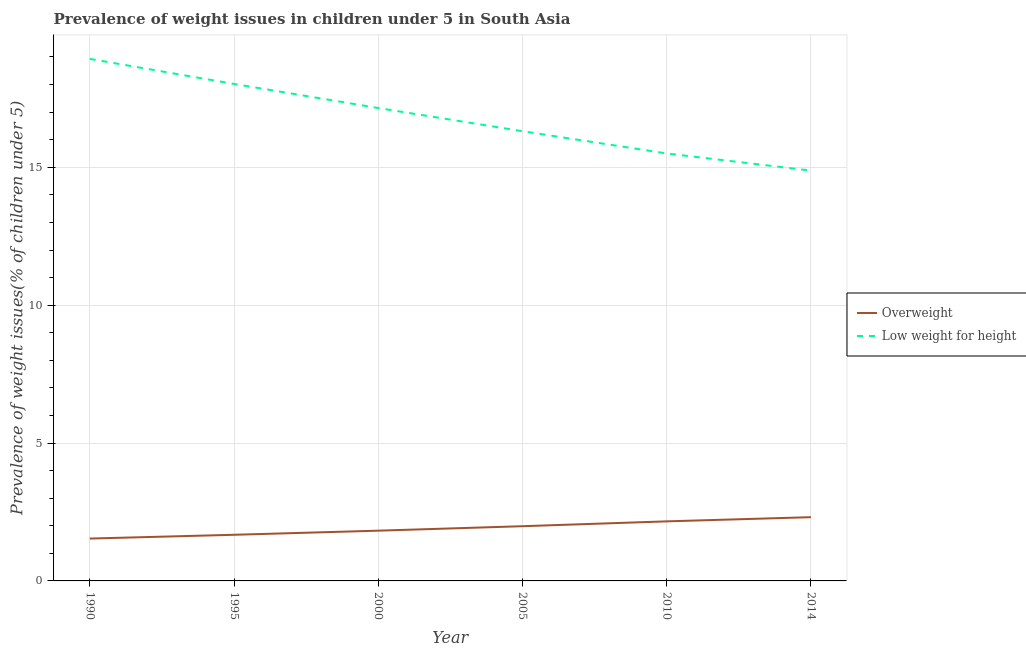How many different coloured lines are there?
Provide a short and direct response. 2. What is the percentage of underweight children in 1990?
Your answer should be compact. 18.93. Across all years, what is the maximum percentage of underweight children?
Make the answer very short. 18.93. Across all years, what is the minimum percentage of overweight children?
Offer a terse response. 1.54. What is the total percentage of underweight children in the graph?
Provide a short and direct response. 100.79. What is the difference between the percentage of underweight children in 2000 and that in 2010?
Your answer should be compact. 1.65. What is the difference between the percentage of overweight children in 2005 and the percentage of underweight children in 2014?
Make the answer very short. -12.9. What is the average percentage of underweight children per year?
Keep it short and to the point. 16.8. In the year 2000, what is the difference between the percentage of underweight children and percentage of overweight children?
Provide a short and direct response. 15.33. What is the ratio of the percentage of underweight children in 1990 to that in 2005?
Your response must be concise. 1.16. What is the difference between the highest and the second highest percentage of overweight children?
Make the answer very short. 0.15. What is the difference between the highest and the lowest percentage of underweight children?
Ensure brevity in your answer.  4.05. Does the percentage of overweight children monotonically increase over the years?
Make the answer very short. Yes. Is the percentage of overweight children strictly greater than the percentage of underweight children over the years?
Offer a terse response. No. Is the percentage of overweight children strictly less than the percentage of underweight children over the years?
Your answer should be very brief. Yes. How many years are there in the graph?
Offer a terse response. 6. Does the graph contain grids?
Your answer should be compact. Yes. Where does the legend appear in the graph?
Provide a succinct answer. Center right. How many legend labels are there?
Your answer should be compact. 2. How are the legend labels stacked?
Provide a short and direct response. Vertical. What is the title of the graph?
Provide a succinct answer. Prevalence of weight issues in children under 5 in South Asia. What is the label or title of the X-axis?
Your answer should be very brief. Year. What is the label or title of the Y-axis?
Offer a terse response. Prevalence of weight issues(% of children under 5). What is the Prevalence of weight issues(% of children under 5) of Overweight in 1990?
Provide a short and direct response. 1.54. What is the Prevalence of weight issues(% of children under 5) of Low weight for height in 1990?
Your response must be concise. 18.93. What is the Prevalence of weight issues(% of children under 5) of Overweight in 1995?
Keep it short and to the point. 1.67. What is the Prevalence of weight issues(% of children under 5) in Low weight for height in 1995?
Keep it short and to the point. 18.02. What is the Prevalence of weight issues(% of children under 5) in Overweight in 2000?
Provide a short and direct response. 1.82. What is the Prevalence of weight issues(% of children under 5) of Low weight for height in 2000?
Make the answer very short. 17.15. What is the Prevalence of weight issues(% of children under 5) in Overweight in 2005?
Make the answer very short. 1.98. What is the Prevalence of weight issues(% of children under 5) of Low weight for height in 2005?
Keep it short and to the point. 16.31. What is the Prevalence of weight issues(% of children under 5) in Overweight in 2010?
Make the answer very short. 2.16. What is the Prevalence of weight issues(% of children under 5) in Low weight for height in 2010?
Your answer should be compact. 15.5. What is the Prevalence of weight issues(% of children under 5) in Overweight in 2014?
Give a very brief answer. 2.31. What is the Prevalence of weight issues(% of children under 5) of Low weight for height in 2014?
Provide a succinct answer. 14.88. Across all years, what is the maximum Prevalence of weight issues(% of children under 5) of Overweight?
Your response must be concise. 2.31. Across all years, what is the maximum Prevalence of weight issues(% of children under 5) of Low weight for height?
Offer a terse response. 18.93. Across all years, what is the minimum Prevalence of weight issues(% of children under 5) of Overweight?
Offer a terse response. 1.54. Across all years, what is the minimum Prevalence of weight issues(% of children under 5) in Low weight for height?
Keep it short and to the point. 14.88. What is the total Prevalence of weight issues(% of children under 5) of Overweight in the graph?
Provide a short and direct response. 11.49. What is the total Prevalence of weight issues(% of children under 5) in Low weight for height in the graph?
Make the answer very short. 100.79. What is the difference between the Prevalence of weight issues(% of children under 5) in Overweight in 1990 and that in 1995?
Your answer should be compact. -0.14. What is the difference between the Prevalence of weight issues(% of children under 5) in Low weight for height in 1990 and that in 1995?
Offer a very short reply. 0.91. What is the difference between the Prevalence of weight issues(% of children under 5) of Overweight in 1990 and that in 2000?
Offer a very short reply. -0.29. What is the difference between the Prevalence of weight issues(% of children under 5) in Low weight for height in 1990 and that in 2000?
Offer a very short reply. 1.78. What is the difference between the Prevalence of weight issues(% of children under 5) in Overweight in 1990 and that in 2005?
Keep it short and to the point. -0.45. What is the difference between the Prevalence of weight issues(% of children under 5) in Low weight for height in 1990 and that in 2005?
Provide a succinct answer. 2.62. What is the difference between the Prevalence of weight issues(% of children under 5) in Overweight in 1990 and that in 2010?
Your answer should be compact. -0.62. What is the difference between the Prevalence of weight issues(% of children under 5) of Low weight for height in 1990 and that in 2010?
Ensure brevity in your answer.  3.43. What is the difference between the Prevalence of weight issues(% of children under 5) of Overweight in 1990 and that in 2014?
Ensure brevity in your answer.  -0.78. What is the difference between the Prevalence of weight issues(% of children under 5) of Low weight for height in 1990 and that in 2014?
Provide a succinct answer. 4.05. What is the difference between the Prevalence of weight issues(% of children under 5) in Overweight in 1995 and that in 2000?
Provide a short and direct response. -0.15. What is the difference between the Prevalence of weight issues(% of children under 5) in Low weight for height in 1995 and that in 2000?
Your response must be concise. 0.87. What is the difference between the Prevalence of weight issues(% of children under 5) in Overweight in 1995 and that in 2005?
Your answer should be very brief. -0.31. What is the difference between the Prevalence of weight issues(% of children under 5) in Low weight for height in 1995 and that in 2005?
Provide a succinct answer. 1.71. What is the difference between the Prevalence of weight issues(% of children under 5) in Overweight in 1995 and that in 2010?
Offer a terse response. -0.49. What is the difference between the Prevalence of weight issues(% of children under 5) of Low weight for height in 1995 and that in 2010?
Give a very brief answer. 2.52. What is the difference between the Prevalence of weight issues(% of children under 5) in Overweight in 1995 and that in 2014?
Give a very brief answer. -0.64. What is the difference between the Prevalence of weight issues(% of children under 5) in Low weight for height in 1995 and that in 2014?
Ensure brevity in your answer.  3.14. What is the difference between the Prevalence of weight issues(% of children under 5) of Overweight in 2000 and that in 2005?
Your response must be concise. -0.16. What is the difference between the Prevalence of weight issues(% of children under 5) in Low weight for height in 2000 and that in 2005?
Your answer should be very brief. 0.84. What is the difference between the Prevalence of weight issues(% of children under 5) in Overweight in 2000 and that in 2010?
Your answer should be very brief. -0.34. What is the difference between the Prevalence of weight issues(% of children under 5) in Low weight for height in 2000 and that in 2010?
Keep it short and to the point. 1.65. What is the difference between the Prevalence of weight issues(% of children under 5) in Overweight in 2000 and that in 2014?
Provide a succinct answer. -0.49. What is the difference between the Prevalence of weight issues(% of children under 5) of Low weight for height in 2000 and that in 2014?
Ensure brevity in your answer.  2.27. What is the difference between the Prevalence of weight issues(% of children under 5) in Overweight in 2005 and that in 2010?
Your response must be concise. -0.18. What is the difference between the Prevalence of weight issues(% of children under 5) in Low weight for height in 2005 and that in 2010?
Keep it short and to the point. 0.81. What is the difference between the Prevalence of weight issues(% of children under 5) in Overweight in 2005 and that in 2014?
Your answer should be very brief. -0.33. What is the difference between the Prevalence of weight issues(% of children under 5) in Low weight for height in 2005 and that in 2014?
Ensure brevity in your answer.  1.43. What is the difference between the Prevalence of weight issues(% of children under 5) of Overweight in 2010 and that in 2014?
Offer a very short reply. -0.15. What is the difference between the Prevalence of weight issues(% of children under 5) in Low weight for height in 2010 and that in 2014?
Make the answer very short. 0.62. What is the difference between the Prevalence of weight issues(% of children under 5) of Overweight in 1990 and the Prevalence of weight issues(% of children under 5) of Low weight for height in 1995?
Give a very brief answer. -16.49. What is the difference between the Prevalence of weight issues(% of children under 5) of Overweight in 1990 and the Prevalence of weight issues(% of children under 5) of Low weight for height in 2000?
Offer a very short reply. -15.61. What is the difference between the Prevalence of weight issues(% of children under 5) in Overweight in 1990 and the Prevalence of weight issues(% of children under 5) in Low weight for height in 2005?
Your response must be concise. -14.77. What is the difference between the Prevalence of weight issues(% of children under 5) of Overweight in 1990 and the Prevalence of weight issues(% of children under 5) of Low weight for height in 2010?
Your answer should be compact. -13.97. What is the difference between the Prevalence of weight issues(% of children under 5) of Overweight in 1990 and the Prevalence of weight issues(% of children under 5) of Low weight for height in 2014?
Your response must be concise. -13.34. What is the difference between the Prevalence of weight issues(% of children under 5) of Overweight in 1995 and the Prevalence of weight issues(% of children under 5) of Low weight for height in 2000?
Offer a terse response. -15.48. What is the difference between the Prevalence of weight issues(% of children under 5) of Overweight in 1995 and the Prevalence of weight issues(% of children under 5) of Low weight for height in 2005?
Keep it short and to the point. -14.63. What is the difference between the Prevalence of weight issues(% of children under 5) of Overweight in 1995 and the Prevalence of weight issues(% of children under 5) of Low weight for height in 2010?
Keep it short and to the point. -13.83. What is the difference between the Prevalence of weight issues(% of children under 5) in Overweight in 1995 and the Prevalence of weight issues(% of children under 5) in Low weight for height in 2014?
Your answer should be very brief. -13.21. What is the difference between the Prevalence of weight issues(% of children under 5) of Overweight in 2000 and the Prevalence of weight issues(% of children under 5) of Low weight for height in 2005?
Offer a very short reply. -14.49. What is the difference between the Prevalence of weight issues(% of children under 5) in Overweight in 2000 and the Prevalence of weight issues(% of children under 5) in Low weight for height in 2010?
Your answer should be very brief. -13.68. What is the difference between the Prevalence of weight issues(% of children under 5) in Overweight in 2000 and the Prevalence of weight issues(% of children under 5) in Low weight for height in 2014?
Your answer should be compact. -13.06. What is the difference between the Prevalence of weight issues(% of children under 5) of Overweight in 2005 and the Prevalence of weight issues(% of children under 5) of Low weight for height in 2010?
Offer a terse response. -13.52. What is the difference between the Prevalence of weight issues(% of children under 5) of Overweight in 2005 and the Prevalence of weight issues(% of children under 5) of Low weight for height in 2014?
Ensure brevity in your answer.  -12.9. What is the difference between the Prevalence of weight issues(% of children under 5) in Overweight in 2010 and the Prevalence of weight issues(% of children under 5) in Low weight for height in 2014?
Your answer should be very brief. -12.72. What is the average Prevalence of weight issues(% of children under 5) of Overweight per year?
Provide a short and direct response. 1.91. What is the average Prevalence of weight issues(% of children under 5) in Low weight for height per year?
Give a very brief answer. 16.8. In the year 1990, what is the difference between the Prevalence of weight issues(% of children under 5) of Overweight and Prevalence of weight issues(% of children under 5) of Low weight for height?
Keep it short and to the point. -17.4. In the year 1995, what is the difference between the Prevalence of weight issues(% of children under 5) of Overweight and Prevalence of weight issues(% of children under 5) of Low weight for height?
Provide a short and direct response. -16.35. In the year 2000, what is the difference between the Prevalence of weight issues(% of children under 5) of Overweight and Prevalence of weight issues(% of children under 5) of Low weight for height?
Your response must be concise. -15.33. In the year 2005, what is the difference between the Prevalence of weight issues(% of children under 5) of Overweight and Prevalence of weight issues(% of children under 5) of Low weight for height?
Ensure brevity in your answer.  -14.32. In the year 2010, what is the difference between the Prevalence of weight issues(% of children under 5) in Overweight and Prevalence of weight issues(% of children under 5) in Low weight for height?
Offer a terse response. -13.34. In the year 2014, what is the difference between the Prevalence of weight issues(% of children under 5) of Overweight and Prevalence of weight issues(% of children under 5) of Low weight for height?
Your answer should be compact. -12.57. What is the ratio of the Prevalence of weight issues(% of children under 5) in Overweight in 1990 to that in 1995?
Offer a very short reply. 0.92. What is the ratio of the Prevalence of weight issues(% of children under 5) in Low weight for height in 1990 to that in 1995?
Your answer should be very brief. 1.05. What is the ratio of the Prevalence of weight issues(% of children under 5) of Overweight in 1990 to that in 2000?
Give a very brief answer. 0.84. What is the ratio of the Prevalence of weight issues(% of children under 5) in Low weight for height in 1990 to that in 2000?
Your answer should be compact. 1.1. What is the ratio of the Prevalence of weight issues(% of children under 5) of Overweight in 1990 to that in 2005?
Keep it short and to the point. 0.77. What is the ratio of the Prevalence of weight issues(% of children under 5) in Low weight for height in 1990 to that in 2005?
Your answer should be compact. 1.16. What is the ratio of the Prevalence of weight issues(% of children under 5) in Overweight in 1990 to that in 2010?
Offer a very short reply. 0.71. What is the ratio of the Prevalence of weight issues(% of children under 5) of Low weight for height in 1990 to that in 2010?
Ensure brevity in your answer.  1.22. What is the ratio of the Prevalence of weight issues(% of children under 5) in Overweight in 1990 to that in 2014?
Make the answer very short. 0.66. What is the ratio of the Prevalence of weight issues(% of children under 5) of Low weight for height in 1990 to that in 2014?
Keep it short and to the point. 1.27. What is the ratio of the Prevalence of weight issues(% of children under 5) of Overweight in 1995 to that in 2000?
Provide a succinct answer. 0.92. What is the ratio of the Prevalence of weight issues(% of children under 5) of Low weight for height in 1995 to that in 2000?
Your answer should be very brief. 1.05. What is the ratio of the Prevalence of weight issues(% of children under 5) in Overweight in 1995 to that in 2005?
Your answer should be compact. 0.84. What is the ratio of the Prevalence of weight issues(% of children under 5) in Low weight for height in 1995 to that in 2005?
Your answer should be compact. 1.11. What is the ratio of the Prevalence of weight issues(% of children under 5) of Overweight in 1995 to that in 2010?
Your answer should be compact. 0.77. What is the ratio of the Prevalence of weight issues(% of children under 5) of Low weight for height in 1995 to that in 2010?
Your response must be concise. 1.16. What is the ratio of the Prevalence of weight issues(% of children under 5) of Overweight in 1995 to that in 2014?
Provide a short and direct response. 0.72. What is the ratio of the Prevalence of weight issues(% of children under 5) in Low weight for height in 1995 to that in 2014?
Your answer should be very brief. 1.21. What is the ratio of the Prevalence of weight issues(% of children under 5) in Overweight in 2000 to that in 2005?
Provide a succinct answer. 0.92. What is the ratio of the Prevalence of weight issues(% of children under 5) of Low weight for height in 2000 to that in 2005?
Offer a very short reply. 1.05. What is the ratio of the Prevalence of weight issues(% of children under 5) of Overweight in 2000 to that in 2010?
Offer a terse response. 0.84. What is the ratio of the Prevalence of weight issues(% of children under 5) in Low weight for height in 2000 to that in 2010?
Provide a succinct answer. 1.11. What is the ratio of the Prevalence of weight issues(% of children under 5) in Overweight in 2000 to that in 2014?
Offer a very short reply. 0.79. What is the ratio of the Prevalence of weight issues(% of children under 5) in Low weight for height in 2000 to that in 2014?
Offer a very short reply. 1.15. What is the ratio of the Prevalence of weight issues(% of children under 5) of Overweight in 2005 to that in 2010?
Offer a very short reply. 0.92. What is the ratio of the Prevalence of weight issues(% of children under 5) in Low weight for height in 2005 to that in 2010?
Make the answer very short. 1.05. What is the ratio of the Prevalence of weight issues(% of children under 5) of Overweight in 2005 to that in 2014?
Offer a very short reply. 0.86. What is the ratio of the Prevalence of weight issues(% of children under 5) of Low weight for height in 2005 to that in 2014?
Give a very brief answer. 1.1. What is the ratio of the Prevalence of weight issues(% of children under 5) of Overweight in 2010 to that in 2014?
Provide a succinct answer. 0.93. What is the ratio of the Prevalence of weight issues(% of children under 5) of Low weight for height in 2010 to that in 2014?
Your answer should be compact. 1.04. What is the difference between the highest and the second highest Prevalence of weight issues(% of children under 5) of Overweight?
Your answer should be compact. 0.15. What is the difference between the highest and the second highest Prevalence of weight issues(% of children under 5) of Low weight for height?
Your response must be concise. 0.91. What is the difference between the highest and the lowest Prevalence of weight issues(% of children under 5) of Overweight?
Provide a short and direct response. 0.78. What is the difference between the highest and the lowest Prevalence of weight issues(% of children under 5) in Low weight for height?
Your answer should be compact. 4.05. 